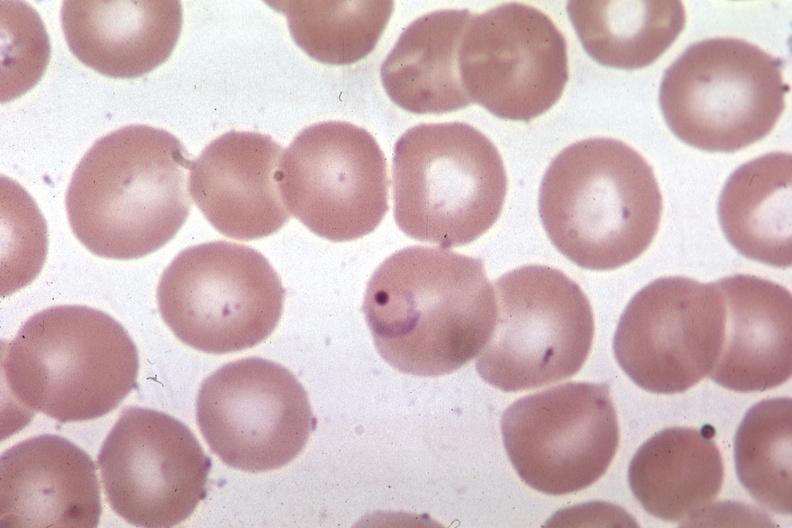does meningioma show ring form?
Answer the question using a single word or phrase. No 